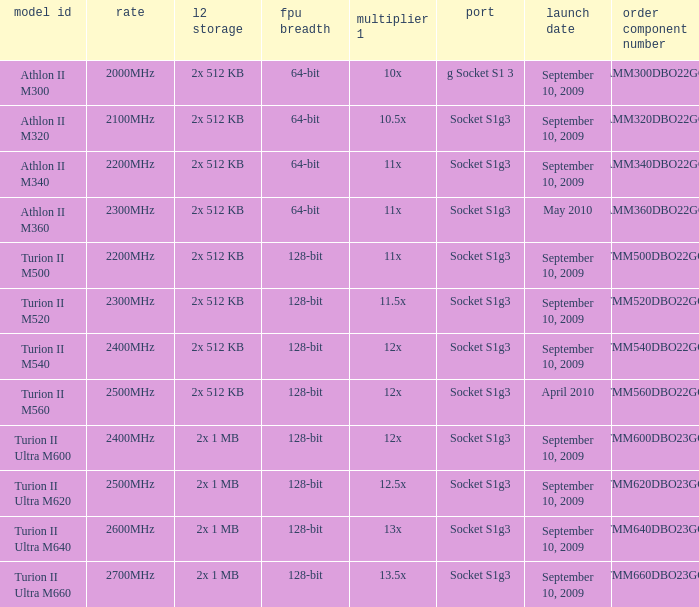What is the L2 cache with a 13.5x multi 1? 2x 1 MB. 